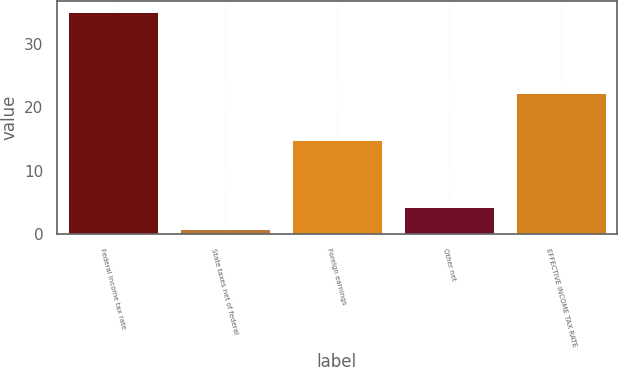<chart> <loc_0><loc_0><loc_500><loc_500><bar_chart><fcel>Federal income tax rate<fcel>State taxes net of federal<fcel>Foreign earnings<fcel>Other net<fcel>EFFECTIVE INCOME TAX RATE<nl><fcel>35<fcel>0.9<fcel>14.8<fcel>4.31<fcel>22.2<nl></chart> 